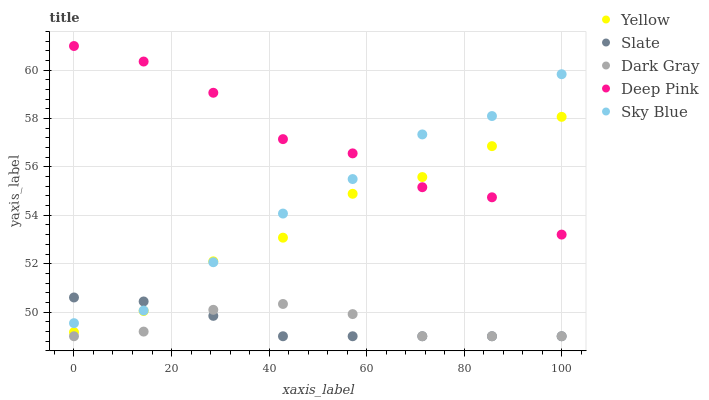Does Slate have the minimum area under the curve?
Answer yes or no. Yes. Does Deep Pink have the maximum area under the curve?
Answer yes or no. Yes. Does Sky Blue have the minimum area under the curve?
Answer yes or no. No. Does Sky Blue have the maximum area under the curve?
Answer yes or no. No. Is Slate the smoothest?
Answer yes or no. Yes. Is Deep Pink the roughest?
Answer yes or no. Yes. Is Sky Blue the smoothest?
Answer yes or no. No. Is Sky Blue the roughest?
Answer yes or no. No. Does Dark Gray have the lowest value?
Answer yes or no. Yes. Does Sky Blue have the lowest value?
Answer yes or no. No. Does Deep Pink have the highest value?
Answer yes or no. Yes. Does Sky Blue have the highest value?
Answer yes or no. No. Is Dark Gray less than Deep Pink?
Answer yes or no. Yes. Is Sky Blue greater than Dark Gray?
Answer yes or no. Yes. Does Yellow intersect Slate?
Answer yes or no. Yes. Is Yellow less than Slate?
Answer yes or no. No. Is Yellow greater than Slate?
Answer yes or no. No. Does Dark Gray intersect Deep Pink?
Answer yes or no. No. 